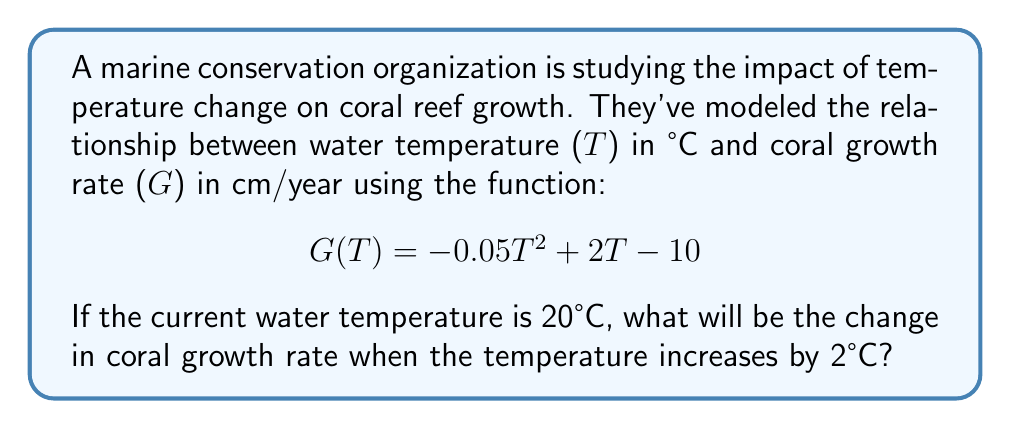Give your solution to this math problem. Let's approach this step-by-step:

1) First, we need to calculate the current growth rate at 20°C:
   $$G(20) = -0.05(20)^2 + 2(20) - 10$$
   $$= -0.05(400) + 40 - 10$$
   $$= -20 + 40 - 10 = 10 \text{ cm/year}$$

2) Now, let's calculate the growth rate at 22°C (after the 2°C increase):
   $$G(22) = -0.05(22)^2 + 2(22) - 10$$
   $$= -0.05(484) + 44 - 10$$
   $$= -24.2 + 44 - 10 = 9.8 \text{ cm/year}$$

3) To find the change in growth rate, we subtract the initial rate from the new rate:
   $$\text{Change} = G(22) - G(20) = 9.8 - 10 = -0.2 \text{ cm/year}$$

Therefore, the change in coral growth rate is a decrease of 0.2 cm/year.
Answer: $-0.2 \text{ cm/year}$ 